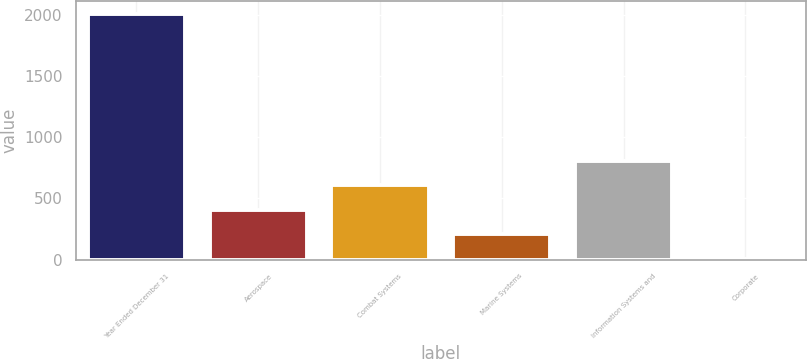Convert chart. <chart><loc_0><loc_0><loc_500><loc_500><bar_chart><fcel>Year Ended December 31<fcel>Aerospace<fcel>Combat Systems<fcel>Marine Systems<fcel>Information Systems and<fcel>Corporate<nl><fcel>2008<fcel>407.2<fcel>607.3<fcel>207.1<fcel>807.4<fcel>7<nl></chart> 